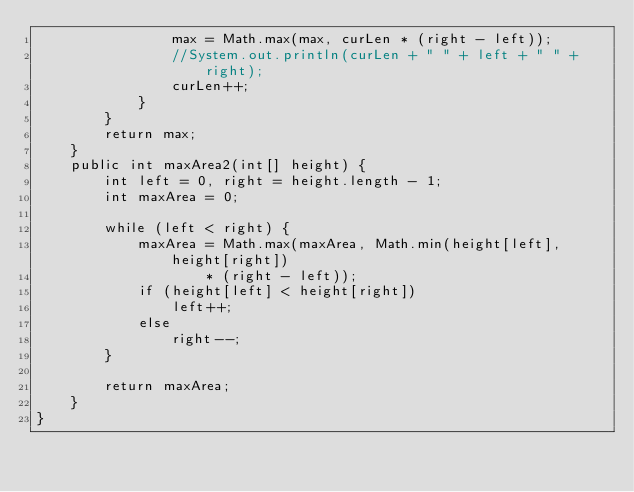Convert code to text. <code><loc_0><loc_0><loc_500><loc_500><_Java_>                max = Math.max(max, curLen * (right - left));
                //System.out.println(curLen + " " + left + " " + right);
                curLen++;
            }
        }
        return max;
    }
    public int maxArea2(int[] height) {
        int left = 0, right = height.length - 1;
        int maxArea = 0;

        while (left < right) {
            maxArea = Math.max(maxArea, Math.min(height[left], height[right])
                    * (right - left));
            if (height[left] < height[right])
                left++;
            else
                right--;
        }

        return maxArea;
    }
}
</code> 